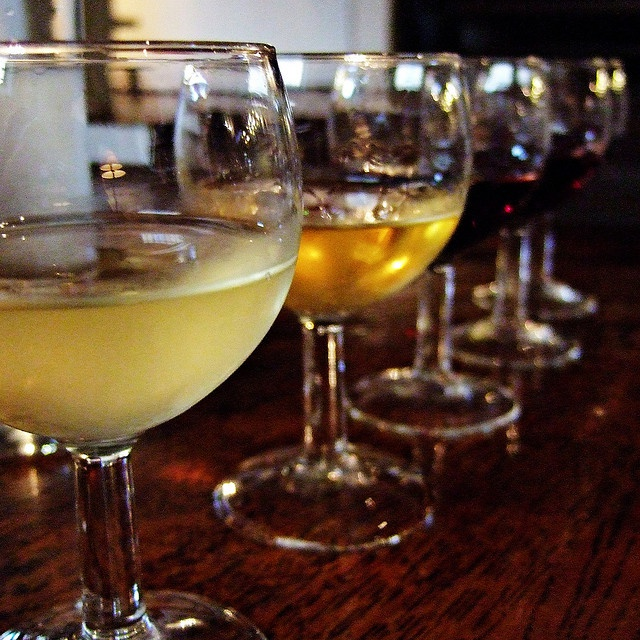Describe the objects in this image and their specific colors. I can see wine glass in darkgray, black, tan, and gray tones, dining table in darkgray, black, maroon, and brown tones, wine glass in darkgray, black, maroon, olive, and gray tones, wine glass in darkgray, black, maroon, and gray tones, and wine glass in darkgray, black, maroon, and gray tones in this image. 